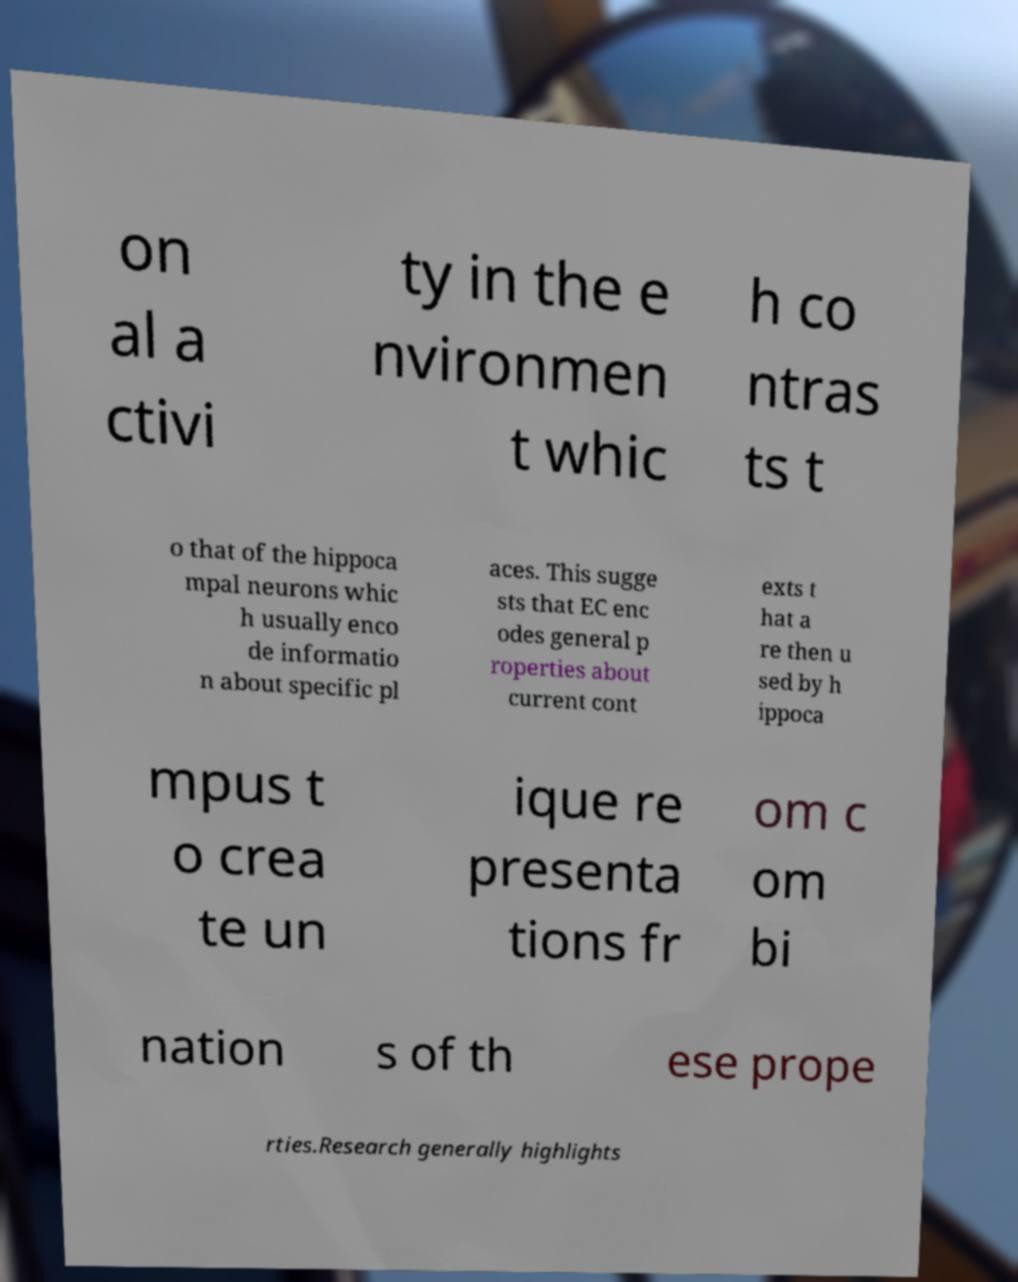Please identify and transcribe the text found in this image. on al a ctivi ty in the e nvironmen t whic h co ntras ts t o that of the hippoca mpal neurons whic h usually enco de informatio n about specific pl aces. This sugge sts that EC enc odes general p roperties about current cont exts t hat a re then u sed by h ippoca mpus t o crea te un ique re presenta tions fr om c om bi nation s of th ese prope rties.Research generally highlights 